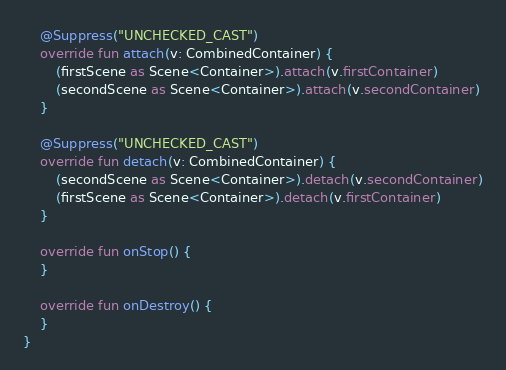Convert code to text. <code><loc_0><loc_0><loc_500><loc_500><_Kotlin_>    @Suppress("UNCHECKED_CAST")
    override fun attach(v: CombinedContainer) {
        (firstScene as Scene<Container>).attach(v.firstContainer)
        (secondScene as Scene<Container>).attach(v.secondContainer)
    }

    @Suppress("UNCHECKED_CAST")
    override fun detach(v: CombinedContainer) {
        (secondScene as Scene<Container>).detach(v.secondContainer)
        (firstScene as Scene<Container>).detach(v.firstContainer)
    }

    override fun onStop() {
    }

    override fun onDestroy() {
    }
}
</code> 